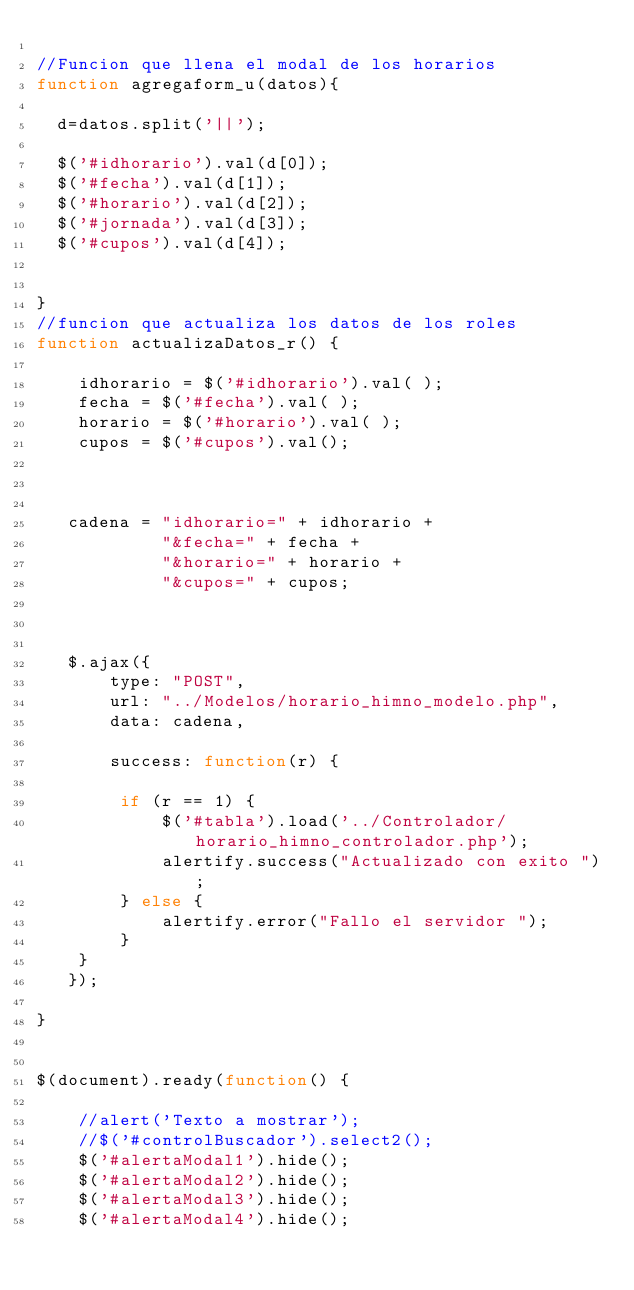<code> <loc_0><loc_0><loc_500><loc_500><_JavaScript_>
//Funcion que llena el modal de los horarios
function agregaform_u(datos){

	d=datos.split('||');

	$('#idhorario').val(d[0]);
	$('#fecha').val(d[1]);
	$('#horario').val(d[2]);
	$('#jornada').val(d[3]);
	$('#cupos').val(d[4]);
	
	
}
//funcion que actualiza los datos de los roles
function actualizaDatos_r() {

    idhorario = $('#idhorario').val( );
    fecha = $('#fecha').val( );
    horario = $('#horario').val( );
    cupos = $('#cupos').val();

   

   cadena = "idhorario=" + idhorario +
            "&fecha=" + fecha +
            "&horario=" + horario +
            "&cupos=" + cupos;



   $.ajax({
       type: "POST",
       url: "../Modelos/horario_himno_modelo.php",
       data: cadena,
       
       success: function(r) {

        if (r == 1) {
            $('#tabla').load('../Controlador/horario_himno_controlador.php');
            alertify.success("Actualizado con exito ");
        } else {
            alertify.error("Fallo el servidor ");
        }
    }
   });
  
}


$(document).ready(function() {

    //alert('Texto a mostrar');
    //$('#controlBuscador').select2();
    $('#alertaModal1').hide();
    $('#alertaModal2').hide();
    $('#alertaModal3').hide();
    $('#alertaModal4').hide();</code> 